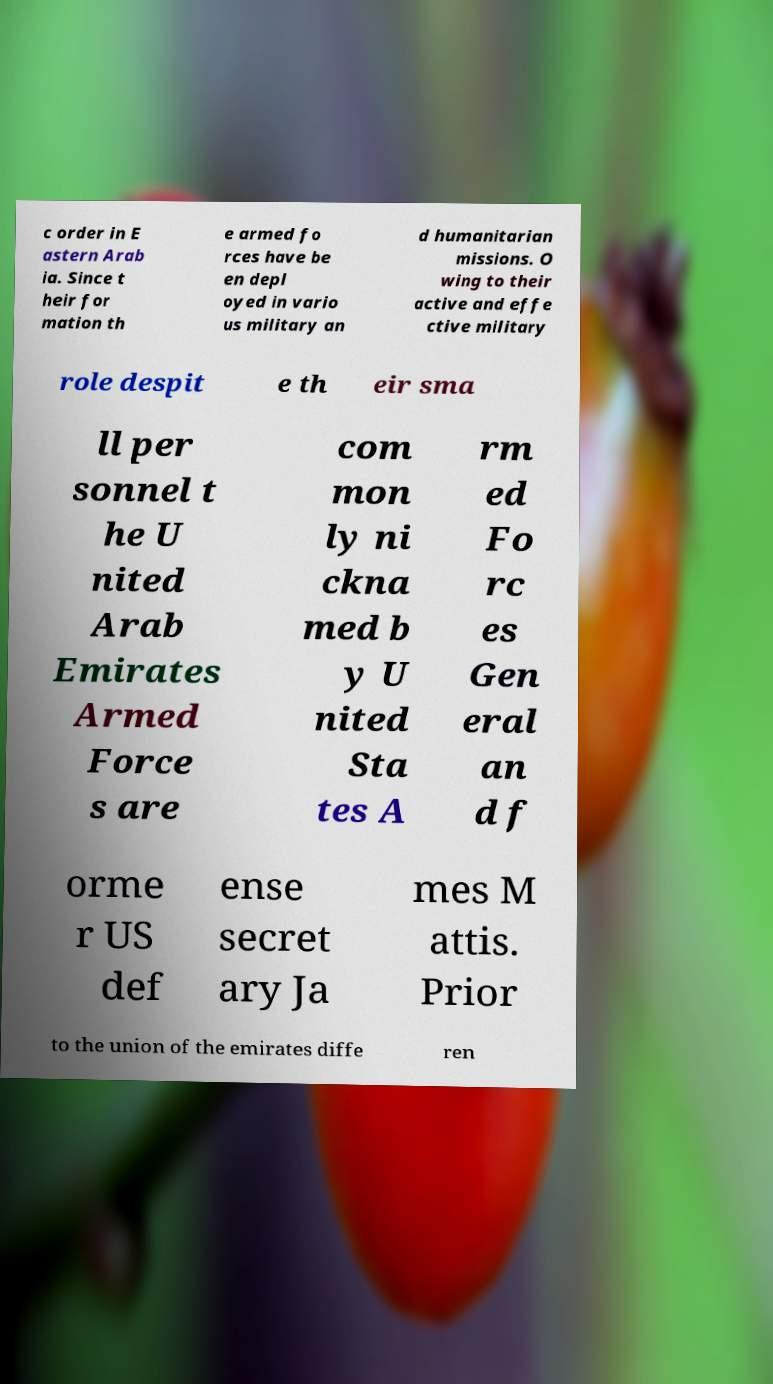Please identify and transcribe the text found in this image. c order in E astern Arab ia. Since t heir for mation th e armed fo rces have be en depl oyed in vario us military an d humanitarian missions. O wing to their active and effe ctive military role despit e th eir sma ll per sonnel t he U nited Arab Emirates Armed Force s are com mon ly ni ckna med b y U nited Sta tes A rm ed Fo rc es Gen eral an d f orme r US def ense secret ary Ja mes M attis. Prior to the union of the emirates diffe ren 